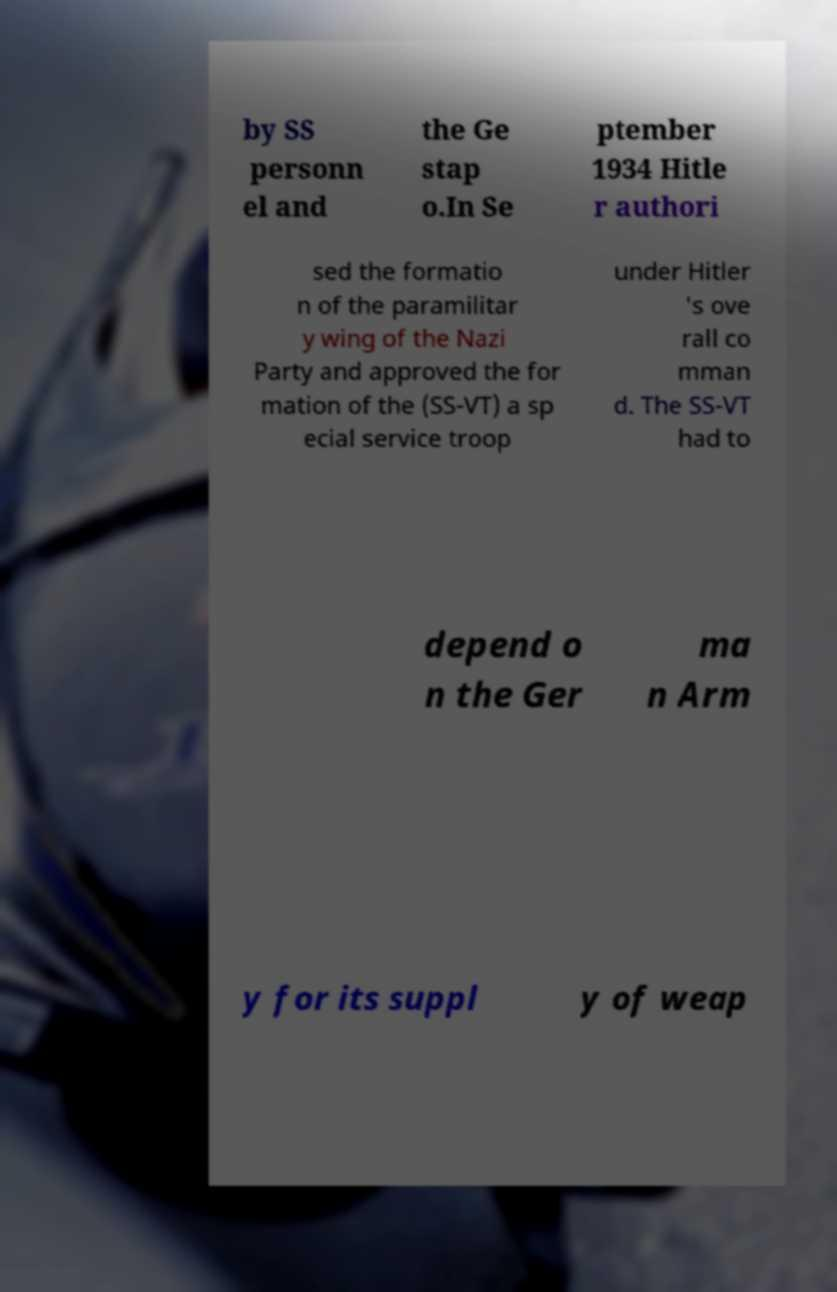I need the written content from this picture converted into text. Can you do that? by SS personn el and the Ge stap o.In Se ptember 1934 Hitle r authori sed the formatio n of the paramilitar y wing of the Nazi Party and approved the for mation of the (SS-VT) a sp ecial service troop under Hitler 's ove rall co mman d. The SS-VT had to depend o n the Ger ma n Arm y for its suppl y of weap 